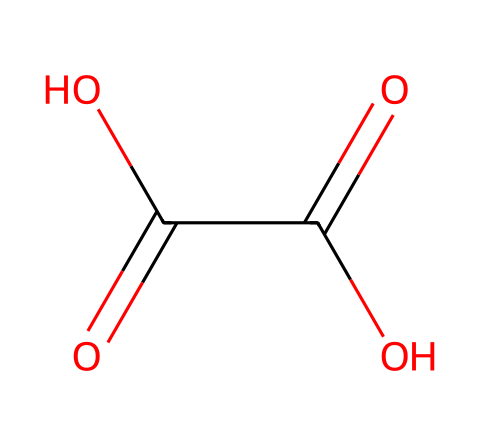How many carbon atoms are present in this chemical? The SMILES representation shows two distinct carbon atoms connected by a single bond. Each carbon atom is represented as 'C' in the structure, and counting them gives a total of two.
Answer: two What is the oxidation state of the carbon atoms in this compound? To determine the oxidation state, we note that carbon in carboxylic groups (like this one) typically has an oxidation state of +3 for the carbonyl (C=O) and +1 for the hydroxyl (C-OH) groups here. With one carbon in a carbonyl and one bonded to hydroxyl groups, the average oxidation state for both carbons would be around +2.
Answer: +2 What functional groups are present in this structure? The chemical features two carboxylic acid functional groups, indicated by the presence of -COOH (carboxyl) and C=O. The -OH group confirms the acidic nature.
Answer: carboxylic acid Is this chemical likely to be a strong acid? The presence of multiple carboxylic acid groups suggests that this compound can donate more than one proton, which typically indicates it is a strong acid. However, its acidity can also depend on other factors, leading to a conclusion that it is a weak acid due to limited dissociation in a solution.
Answer: weak acid What is the potential effect of oxalic acid on family dynamics when used in cleaners? Oxalic acid is often used in household cleaners as a powerful stain remover. If used improperly, it could lead to health risks, prompting family members to avoid these cleaners, thereby impacting relationships by fostering distrust or fear around cleaning tasks.
Answer: distrust 